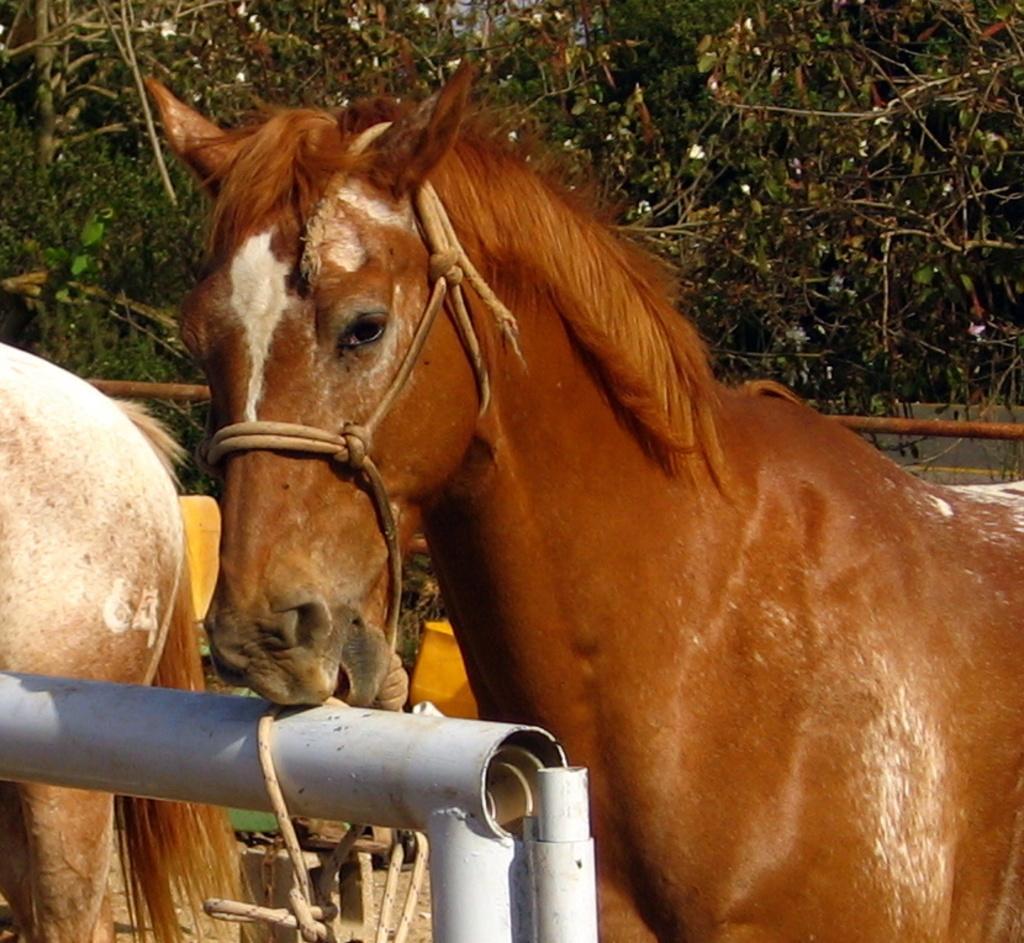In one or two sentences, can you explain what this image depicts? In this image in the center there are horses. In the front there is a pole which is white in colour and in the background there are trees. 